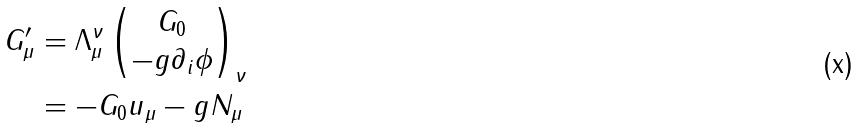Convert formula to latex. <formula><loc_0><loc_0><loc_500><loc_500>G _ { \mu } ^ { \prime } & = \Lambda _ { \mu } ^ { \nu } \begin{pmatrix} G _ { 0 } \\ - g \partial _ { i } \phi \end{pmatrix} _ { \nu } \\ & = - G _ { 0 } u _ { \mu } - g N _ { \mu }</formula> 